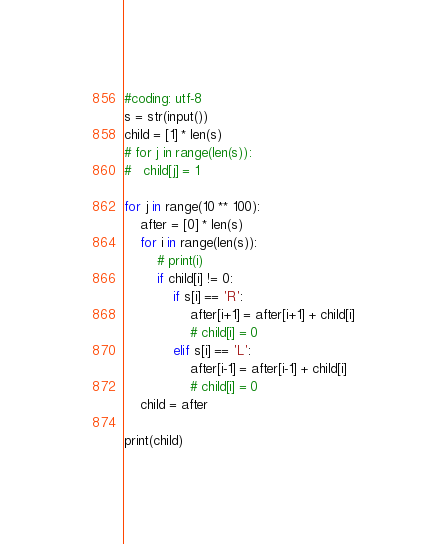Convert code to text. <code><loc_0><loc_0><loc_500><loc_500><_Python_>#coding: utf-8
s = str(input())
child = [1] * len(s)
# for j in range(len(s)):
# 	child[j] = 1

for j in range(10 ** 100):
	after = [0] * len(s)
	for i in range(len(s)):
		# print(i)
		if child[i] != 0:
			if s[i] == 'R':
				after[i+1] = after[i+1] + child[i]
				# child[i] = 0
			elif s[i] == 'L':
				after[i-1] = after[i-1] + child[i]
				# child[i] = 0
	child = after

print(child) 
</code> 